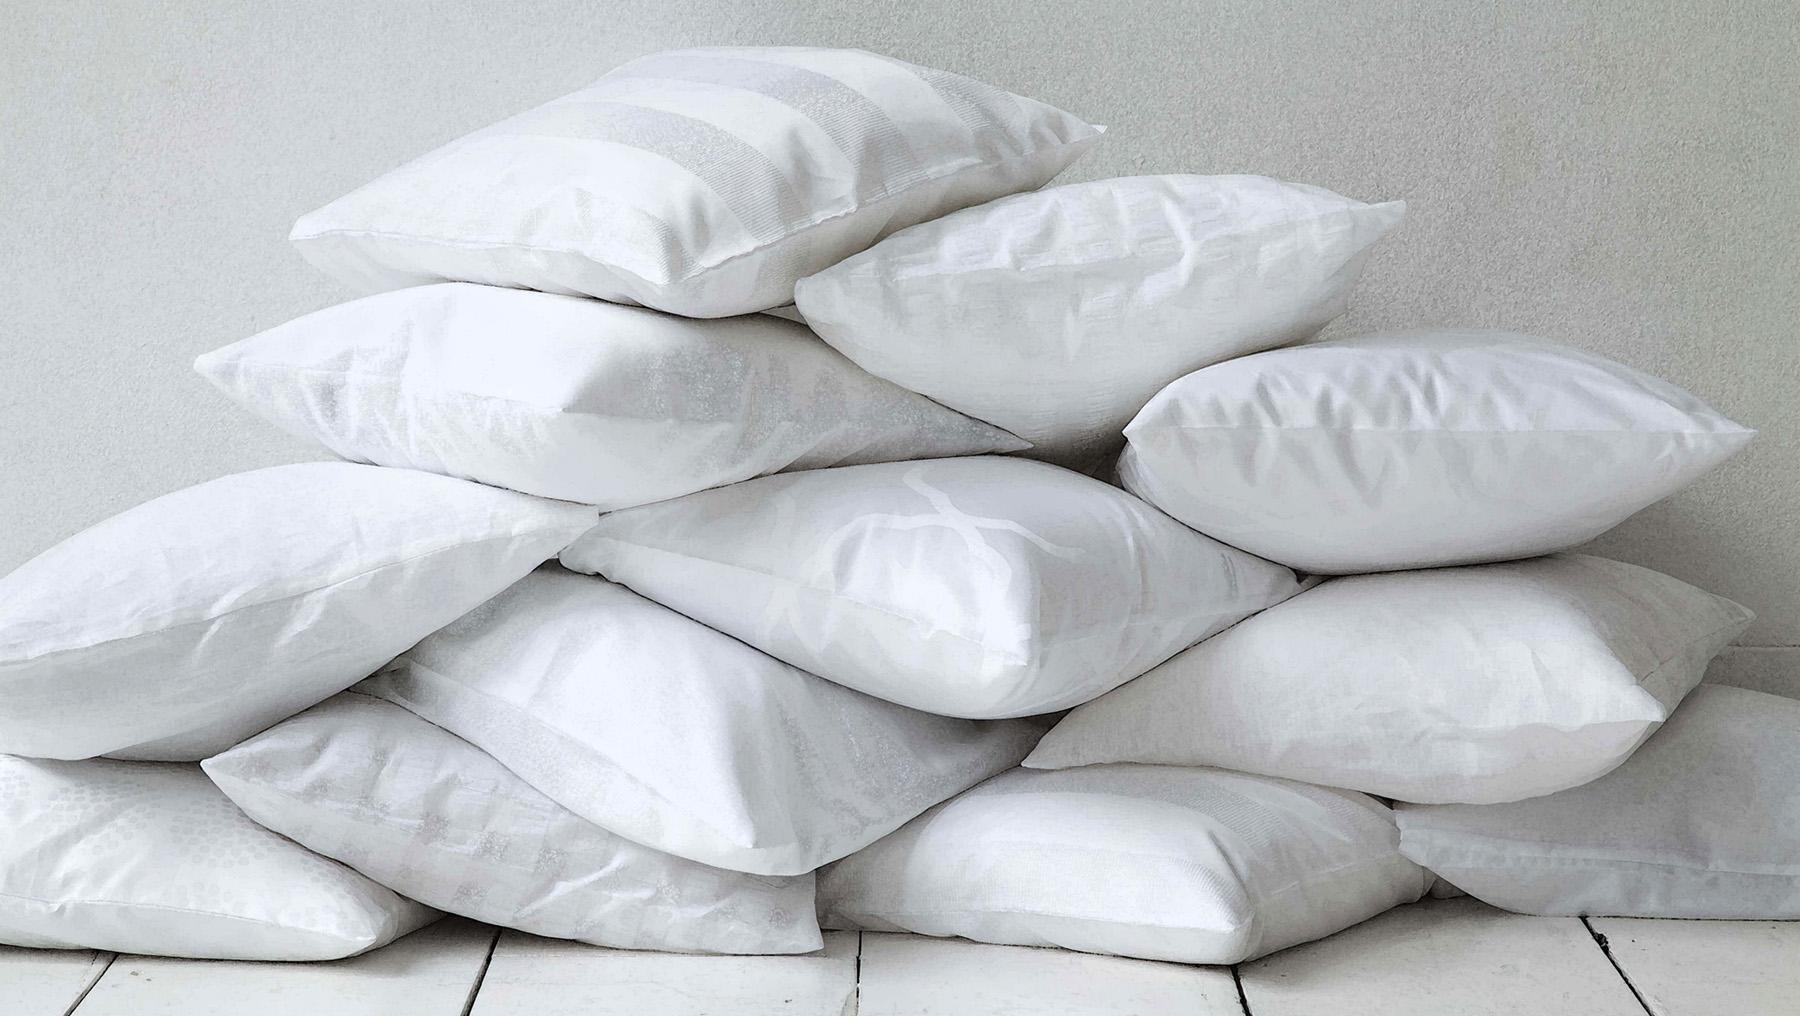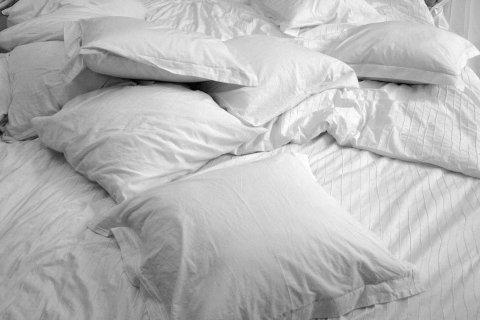The first image is the image on the left, the second image is the image on the right. Considering the images on both sides, is "An image includes a pile of at least 10 white pillows." valid? Answer yes or no. Yes. The first image is the image on the left, the second image is the image on the right. Analyze the images presented: Is the assertion "There is a single uncovered pillow in the left image." valid? Answer yes or no. No. 